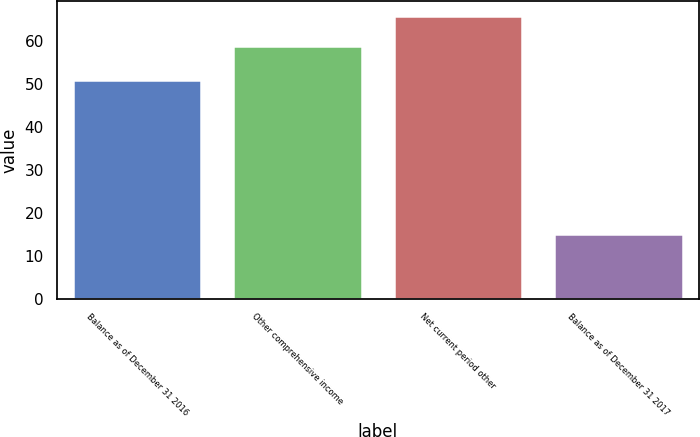Convert chart to OTSL. <chart><loc_0><loc_0><loc_500><loc_500><bar_chart><fcel>Balance as of December 31 2016<fcel>Other comprehensive income<fcel>Net current period other<fcel>Balance as of December 31 2017<nl><fcel>51<fcel>59<fcel>66<fcel>15<nl></chart> 